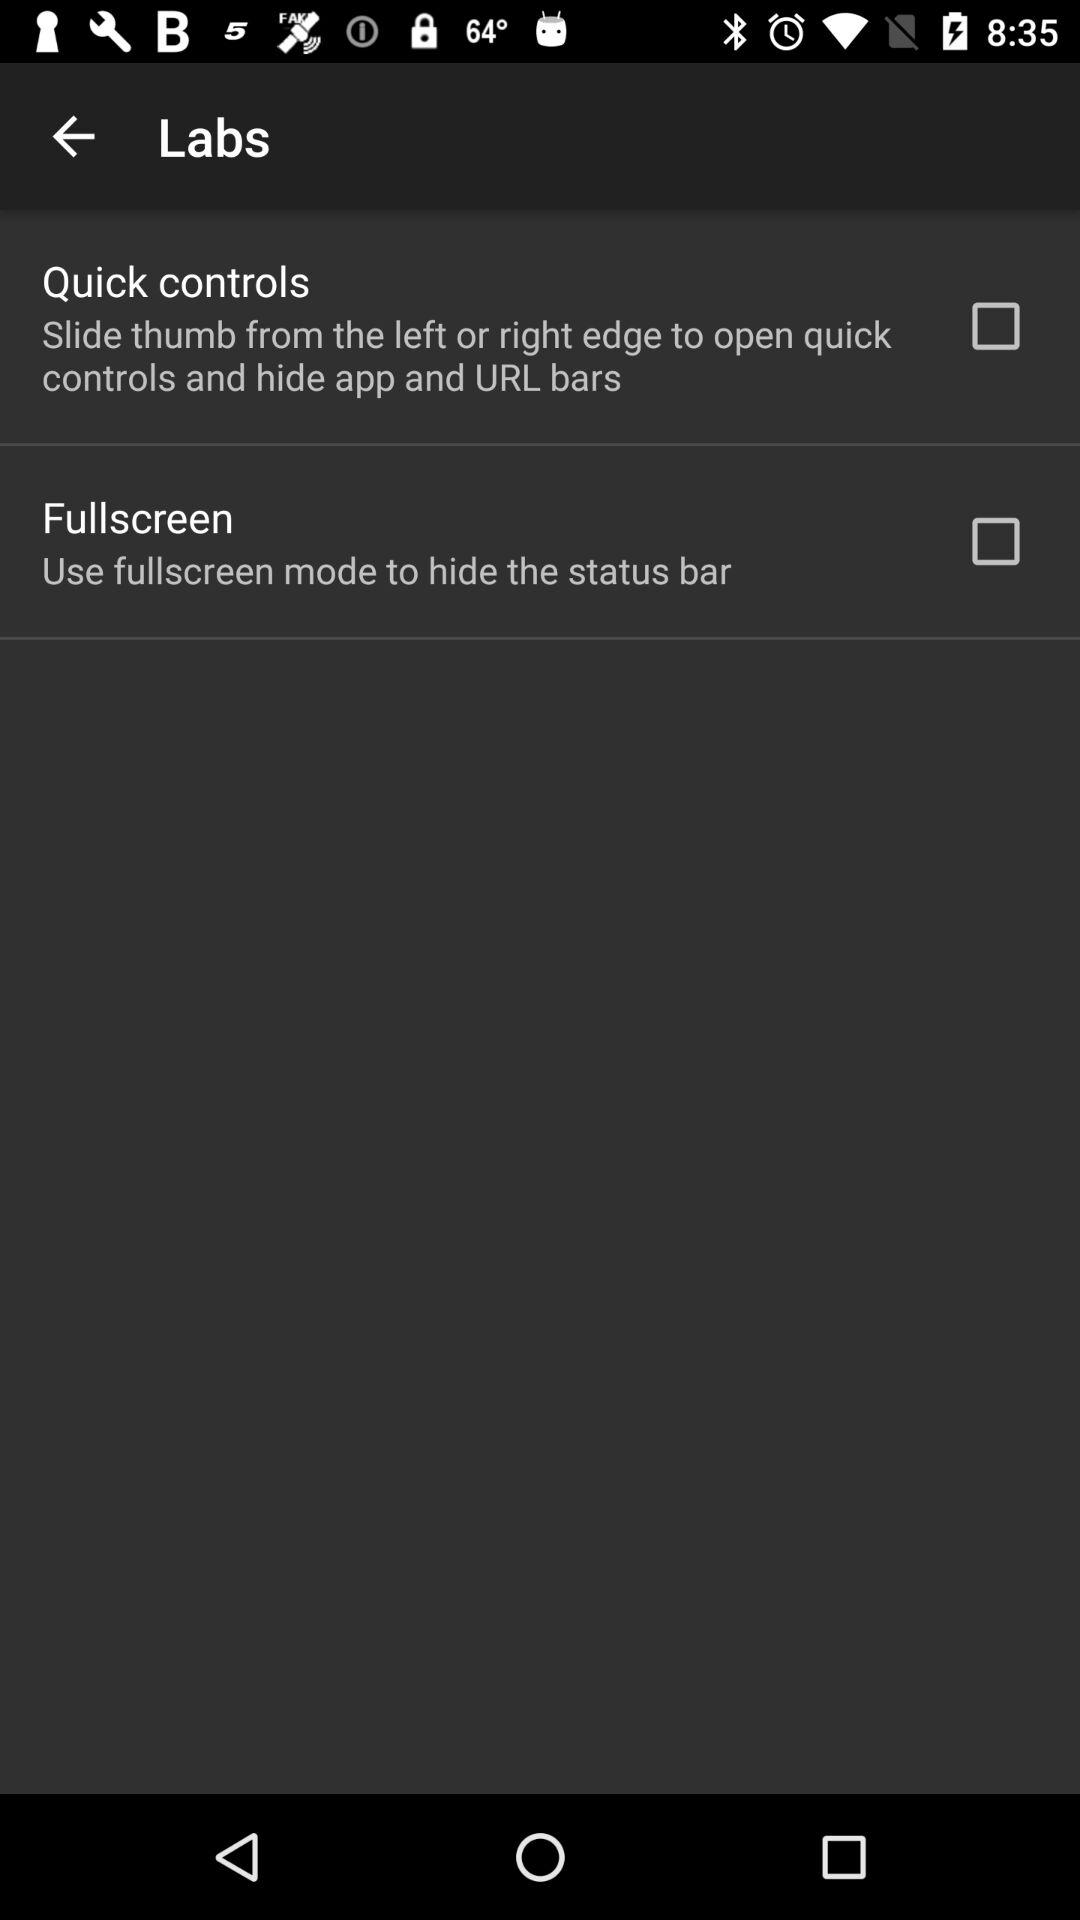What is the setting for full screen mode? The setting is off. 